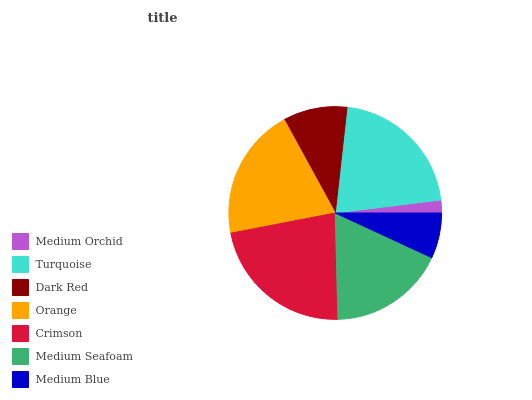Is Medium Orchid the minimum?
Answer yes or no. Yes. Is Crimson the maximum?
Answer yes or no. Yes. Is Turquoise the minimum?
Answer yes or no. No. Is Turquoise the maximum?
Answer yes or no. No. Is Turquoise greater than Medium Orchid?
Answer yes or no. Yes. Is Medium Orchid less than Turquoise?
Answer yes or no. Yes. Is Medium Orchid greater than Turquoise?
Answer yes or no. No. Is Turquoise less than Medium Orchid?
Answer yes or no. No. Is Medium Seafoam the high median?
Answer yes or no. Yes. Is Medium Seafoam the low median?
Answer yes or no. Yes. Is Crimson the high median?
Answer yes or no. No. Is Medium Orchid the low median?
Answer yes or no. No. 